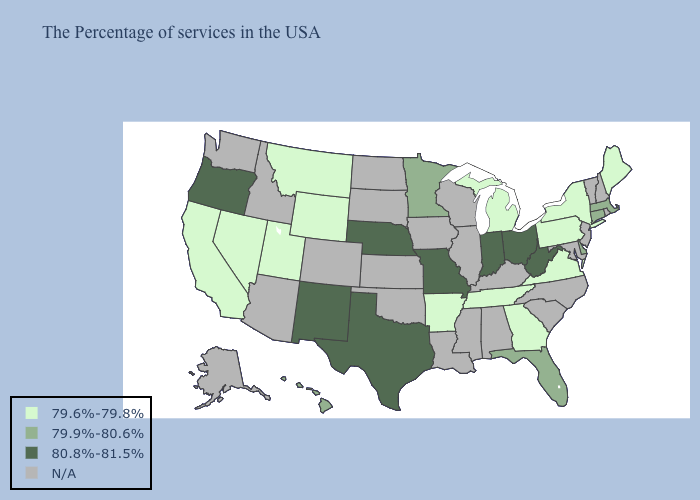How many symbols are there in the legend?
Keep it brief. 4. Among the states that border Wyoming , which have the highest value?
Short answer required. Nebraska. Name the states that have a value in the range N/A?
Give a very brief answer. Rhode Island, New Hampshire, Vermont, New Jersey, Maryland, North Carolina, South Carolina, Kentucky, Alabama, Wisconsin, Illinois, Mississippi, Louisiana, Iowa, Kansas, Oklahoma, South Dakota, North Dakota, Colorado, Arizona, Idaho, Washington, Alaska. Which states have the lowest value in the USA?
Be succinct. Maine, New York, Pennsylvania, Virginia, Georgia, Michigan, Tennessee, Arkansas, Wyoming, Utah, Montana, Nevada, California. What is the lowest value in the South?
Concise answer only. 79.6%-79.8%. Name the states that have a value in the range 80.8%-81.5%?
Be succinct. West Virginia, Ohio, Indiana, Missouri, Nebraska, Texas, New Mexico, Oregon. What is the highest value in the South ?
Give a very brief answer. 80.8%-81.5%. What is the value of Georgia?
Write a very short answer. 79.6%-79.8%. What is the value of Utah?
Short answer required. 79.6%-79.8%. Which states hav the highest value in the Northeast?
Write a very short answer. Massachusetts, Connecticut. Which states have the highest value in the USA?
Keep it brief. West Virginia, Ohio, Indiana, Missouri, Nebraska, Texas, New Mexico, Oregon. What is the lowest value in the USA?
Be succinct. 79.6%-79.8%. What is the value of New York?
Answer briefly. 79.6%-79.8%. 